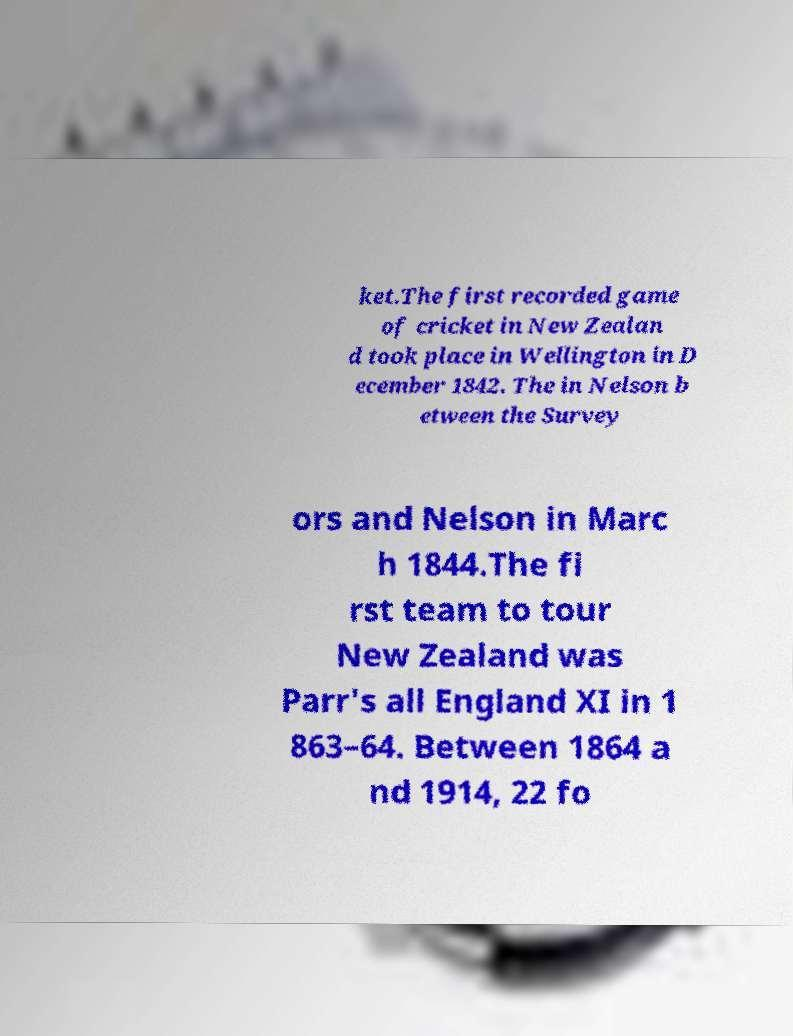Please read and relay the text visible in this image. What does it say? ket.The first recorded game of cricket in New Zealan d took place in Wellington in D ecember 1842. The in Nelson b etween the Survey ors and Nelson in Marc h 1844.The fi rst team to tour New Zealand was Parr's all England XI in 1 863–64. Between 1864 a nd 1914, 22 fo 